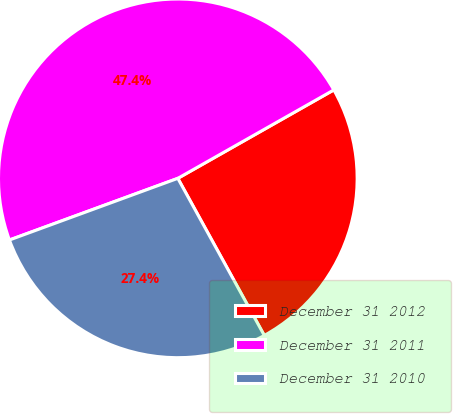Convert chart. <chart><loc_0><loc_0><loc_500><loc_500><pie_chart><fcel>December 31 2012<fcel>December 31 2011<fcel>December 31 2010<nl><fcel>25.2%<fcel>47.38%<fcel>27.42%<nl></chart> 